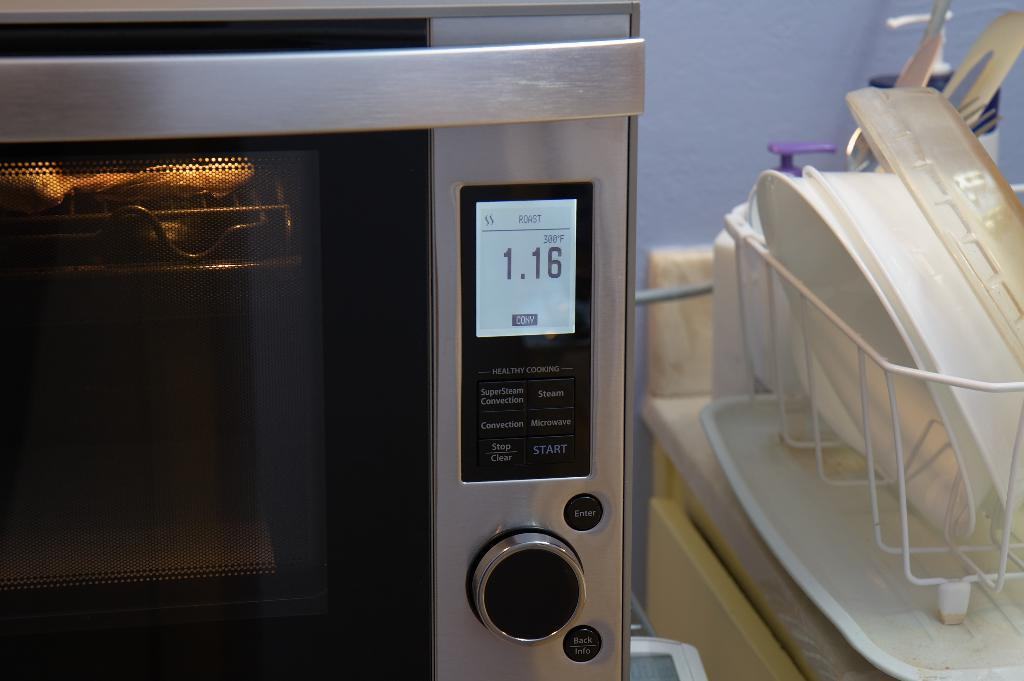What type of appliance is located on the left side of the image? There is an oven on the left side of the image. What can be seen on the right side of the image? There are bowls in an iron frame on the right side of the image. How many chairs are visible in the image? There are no chairs present in the image. What type of animals can be seen at the zoo in the image? There is no zoo present in the image. 